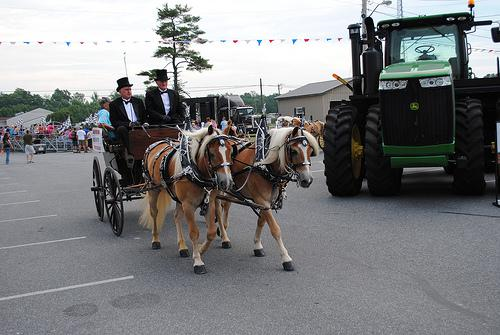Question: who is driving the carriage?
Choices:
A. Two women.
B. Two men.
C. My grandparents.
D. My aunt.
Answer with the letter. Answer: B Question: how many horses are pulling the carriage?
Choices:
A. Two.
B. Three.
C. One.
D. Four.
Answer with the letter. Answer: A Question: what other form of transportation is shown?
Choices:
A. Motorcycle.
B. Tractor.
C. Car.
D. Train.
Answer with the letter. Answer: B Question: where is this photo taking place?
Choices:
A. A museum.
B. A small town.
C. A mall.
D. A beach.
Answer with the letter. Answer: B Question: what color are the drivers' hats?
Choices:
A. White.
B. Blue.
C. Black.
D. Gray.
Answer with the letter. Answer: C 